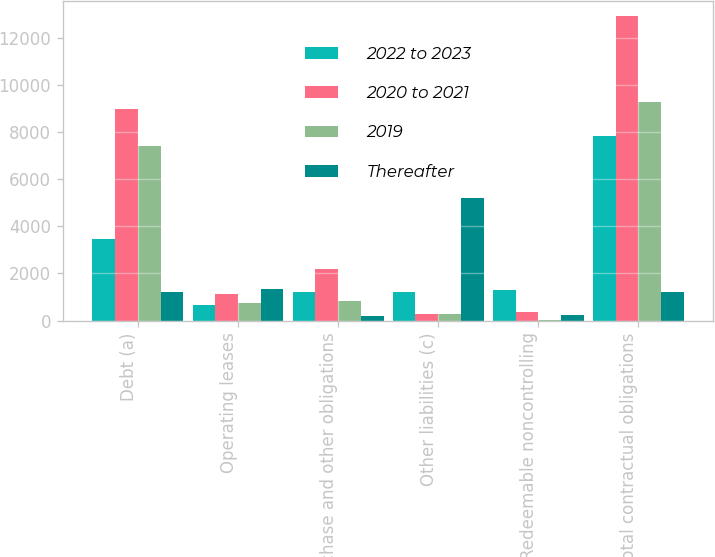<chart> <loc_0><loc_0><loc_500><loc_500><stacked_bar_chart><ecel><fcel>Debt (a)<fcel>Operating leases<fcel>Purchase and other obligations<fcel>Other liabilities (c)<fcel>Redeemable noncontrolling<fcel>Total contractual obligations<nl><fcel>2022 to 2023<fcel>3463<fcel>669<fcel>1216<fcel>1206<fcel>1276<fcel>7830<nl><fcel>2020 to 2021<fcel>8970<fcel>1103<fcel>2205<fcel>260<fcel>380<fcel>12918<nl><fcel>2019<fcel>7396<fcel>761<fcel>808<fcel>257<fcel>25<fcel>9247<nl><fcel>Thereafter<fcel>1211<fcel>1343<fcel>175<fcel>5213<fcel>227<fcel>1211<nl></chart> 